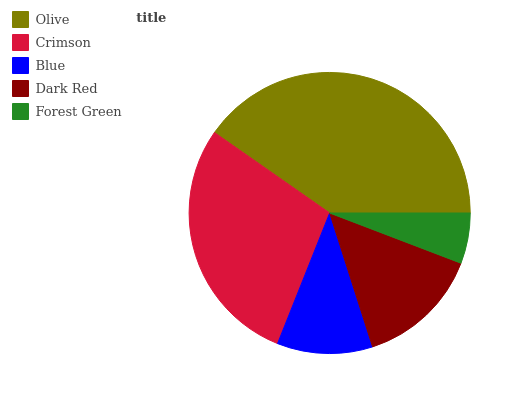Is Forest Green the minimum?
Answer yes or no. Yes. Is Olive the maximum?
Answer yes or no. Yes. Is Crimson the minimum?
Answer yes or no. No. Is Crimson the maximum?
Answer yes or no. No. Is Olive greater than Crimson?
Answer yes or no. Yes. Is Crimson less than Olive?
Answer yes or no. Yes. Is Crimson greater than Olive?
Answer yes or no. No. Is Olive less than Crimson?
Answer yes or no. No. Is Dark Red the high median?
Answer yes or no. Yes. Is Dark Red the low median?
Answer yes or no. Yes. Is Olive the high median?
Answer yes or no. No. Is Forest Green the low median?
Answer yes or no. No. 